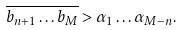<formula> <loc_0><loc_0><loc_500><loc_500>\overline { b _ { n + 1 } \dots b _ { M } } > \alpha _ { 1 } \dots \alpha _ { M - n } .</formula> 